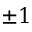<formula> <loc_0><loc_0><loc_500><loc_500>\pm 1</formula> 